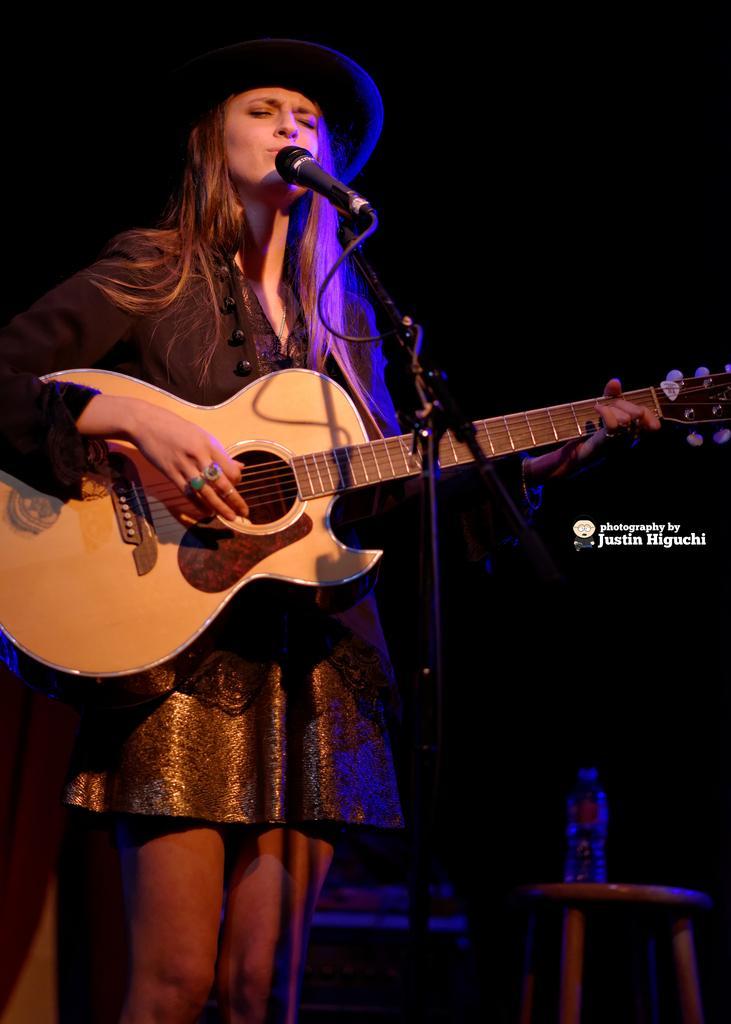Could you give a brief overview of what you see in this image? A woman is singing with mic in front of her while playing a guitar. 